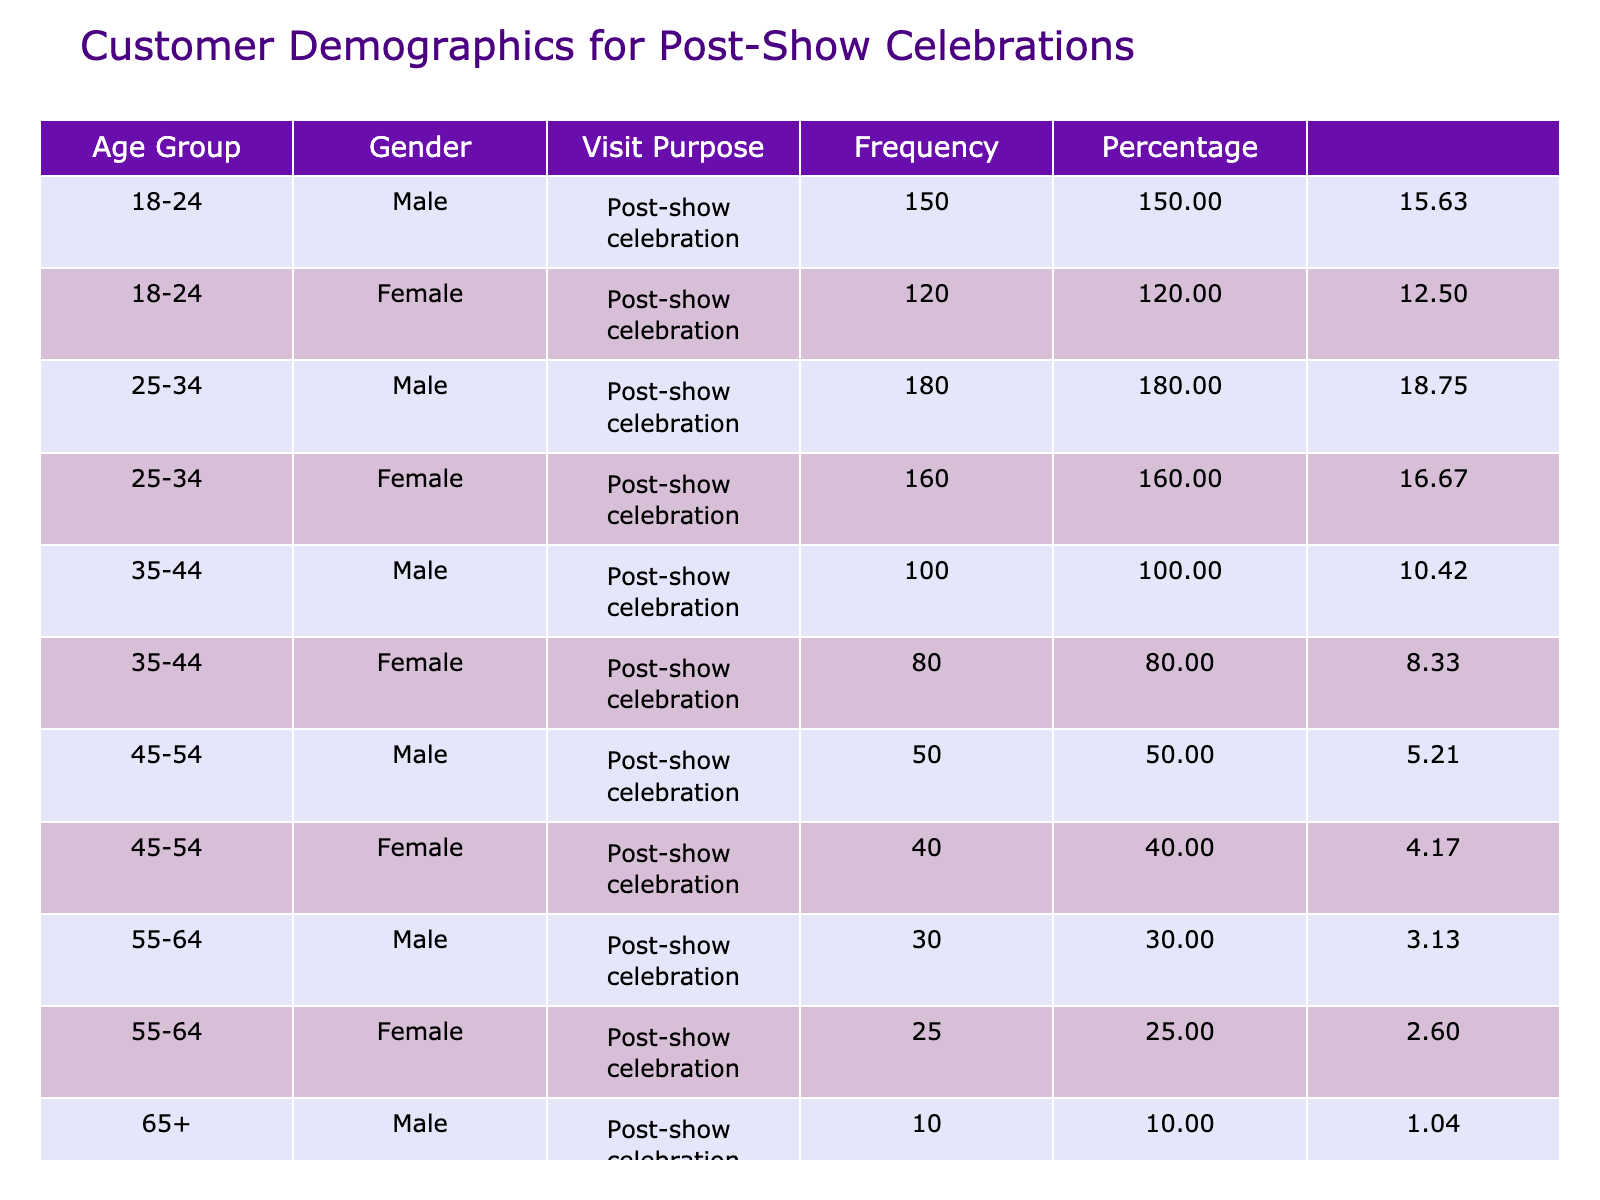What is the total frequency of visits from females in the age group 25-34? From the table, the frequency for females in the age group 25-34 is 160. Therefore, the total frequency for females in that age group is 160.
Answer: 160 What percentage of the total visits is made by males aged 18-24? The total frequency of visits is 1,055 (150 + 120 + 180 + 160 + 100 + 80 + 50 + 40 + 30 + 25 + 10 + 15 = 1,055). The frequency for males aged 18-24 is 150. The percentage is (150 / 1,055) * 100 ≈ 14.2%.
Answer: 14.2% Is it true that more females than males visit the diner from the age group 45-54? For the age group 45-54, the frequency for males is 50 and for females is 40. Since 40 is less than 50, the statement is false.
Answer: No What is the total frequency of visits from customers aged 55 and older? The frequencies for customers aged 55-64 and 65+ are 30, 25, 10, and 15, respectively. Thus, the total frequency is 30 + 25 + 10 + 15 = 80.
Answer: 80 Which age group has the highest number of male visitors? Reviewing the table, the age group 25-34 has the highest frequency for males at 180. Therefore, the answer is the age group 25-34.
Answer: 25-34 What is the difference in frequency between male and female visitors aged 35-44? The frequency for males aged 35-44 is 100 and for females is 80. The difference is 100 - 80 = 20.
Answer: 20 What proportion of the total visits do the youngest customers (age group 18-24) represent? The total frequency of visits is 1,055, and the combined frequency for the 18-24 age group (150 males + 120 females) is 270. The proportion is (270 / 1,055) * 100 ≈ 25.6%.
Answer: 25.6% Which gender contributes more to the total frequency of visits in the age group 65 and older? For the age group 65+, males have a frequency of 10, and females have a frequency of 15. Since 15 > 10, females contribute more.
Answer: Females What is the average frequency of visits across all age groups for male customers? The frequencies for male customers in each age group are 150, 180, 100, 50, 30, and 10. The total for males is 150 + 180 + 100 + 50 + 30 + 10 = 520. There are 6 age groups, so the average frequency is 520 / 6 ≈ 86.67.
Answer: 86.67 